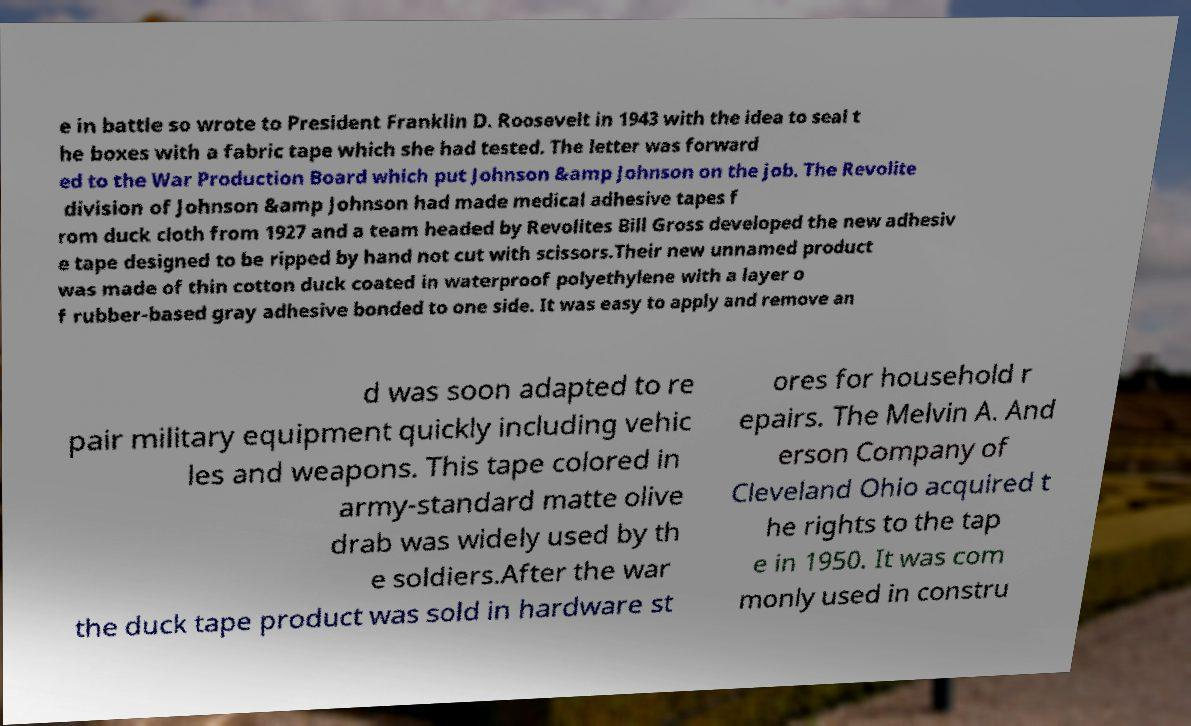There's text embedded in this image that I need extracted. Can you transcribe it verbatim? e in battle so wrote to President Franklin D. Roosevelt in 1943 with the idea to seal t he boxes with a fabric tape which she had tested. The letter was forward ed to the War Production Board which put Johnson &amp Johnson on the job. The Revolite division of Johnson &amp Johnson had made medical adhesive tapes f rom duck cloth from 1927 and a team headed by Revolites Bill Gross developed the new adhesiv e tape designed to be ripped by hand not cut with scissors.Their new unnamed product was made of thin cotton duck coated in waterproof polyethylene with a layer o f rubber-based gray adhesive bonded to one side. It was easy to apply and remove an d was soon adapted to re pair military equipment quickly including vehic les and weapons. This tape colored in army-standard matte olive drab was widely used by th e soldiers.After the war the duck tape product was sold in hardware st ores for household r epairs. The Melvin A. And erson Company of Cleveland Ohio acquired t he rights to the tap e in 1950. It was com monly used in constru 